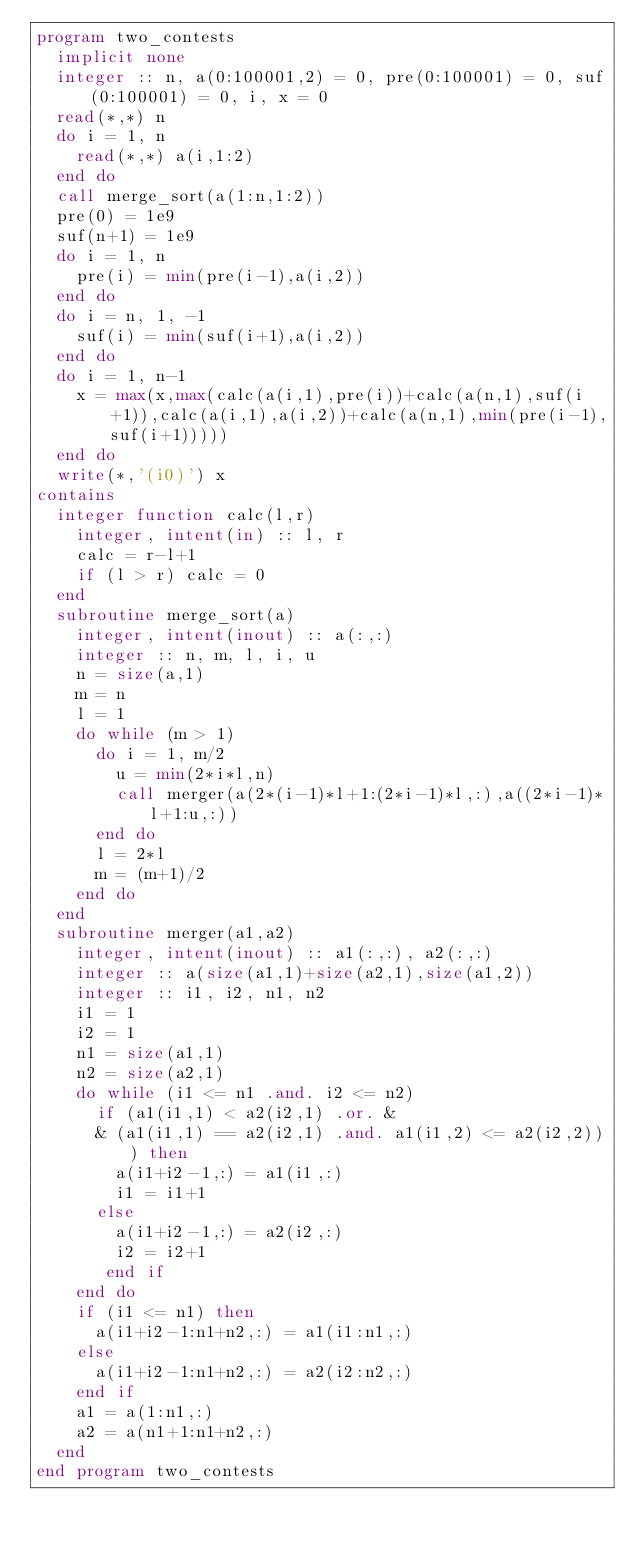Convert code to text. <code><loc_0><loc_0><loc_500><loc_500><_FORTRAN_>program two_contests
  implicit none
  integer :: n, a(0:100001,2) = 0, pre(0:100001) = 0, suf(0:100001) = 0, i, x = 0
  read(*,*) n
  do i = 1, n
    read(*,*) a(i,1:2)
  end do
  call merge_sort(a(1:n,1:2))
  pre(0) = 1e9
  suf(n+1) = 1e9
  do i = 1, n
    pre(i) = min(pre(i-1),a(i,2))
  end do
  do i = n, 1, -1
    suf(i) = min(suf(i+1),a(i,2))
  end do
  do i = 1, n-1
    x = max(x,max(calc(a(i,1),pre(i))+calc(a(n,1),suf(i+1)),calc(a(i,1),a(i,2))+calc(a(n,1),min(pre(i-1),suf(i+1)))))
  end do
  write(*,'(i0)') x
contains
  integer function calc(l,r)
    integer, intent(in) :: l, r
    calc = r-l+1
    if (l > r) calc = 0
  end
  subroutine merge_sort(a)
    integer, intent(inout) :: a(:,:)
    integer :: n, m, l, i, u
    n = size(a,1)
    m = n
    l = 1
    do while (m > 1)
      do i = 1, m/2
        u = min(2*i*l,n)
        call merger(a(2*(i-1)*l+1:(2*i-1)*l,:),a((2*i-1)*l+1:u,:))
      end do
      l = 2*l
      m = (m+1)/2
    end do
  end
  subroutine merger(a1,a2)
    integer, intent(inout) :: a1(:,:), a2(:,:)
    integer :: a(size(a1,1)+size(a2,1),size(a1,2))
    integer :: i1, i2, n1, n2
    i1 = 1
    i2 = 1
    n1 = size(a1,1)
    n2 = size(a2,1)
    do while (i1 <= n1 .and. i2 <= n2)
      if (a1(i1,1) < a2(i2,1) .or. &
      & (a1(i1,1) == a2(i2,1) .and. a1(i1,2) <= a2(i2,2))) then
        a(i1+i2-1,:) = a1(i1,:)
        i1 = i1+1
      else
        a(i1+i2-1,:) = a2(i2,:)
        i2 = i2+1
       end if
    end do
    if (i1 <= n1) then
      a(i1+i2-1:n1+n2,:) = a1(i1:n1,:)
    else
      a(i1+i2-1:n1+n2,:) = a2(i2:n2,:)
    end if
    a1 = a(1:n1,:)
    a2 = a(n1+1:n1+n2,:)
  end
end program two_contests</code> 